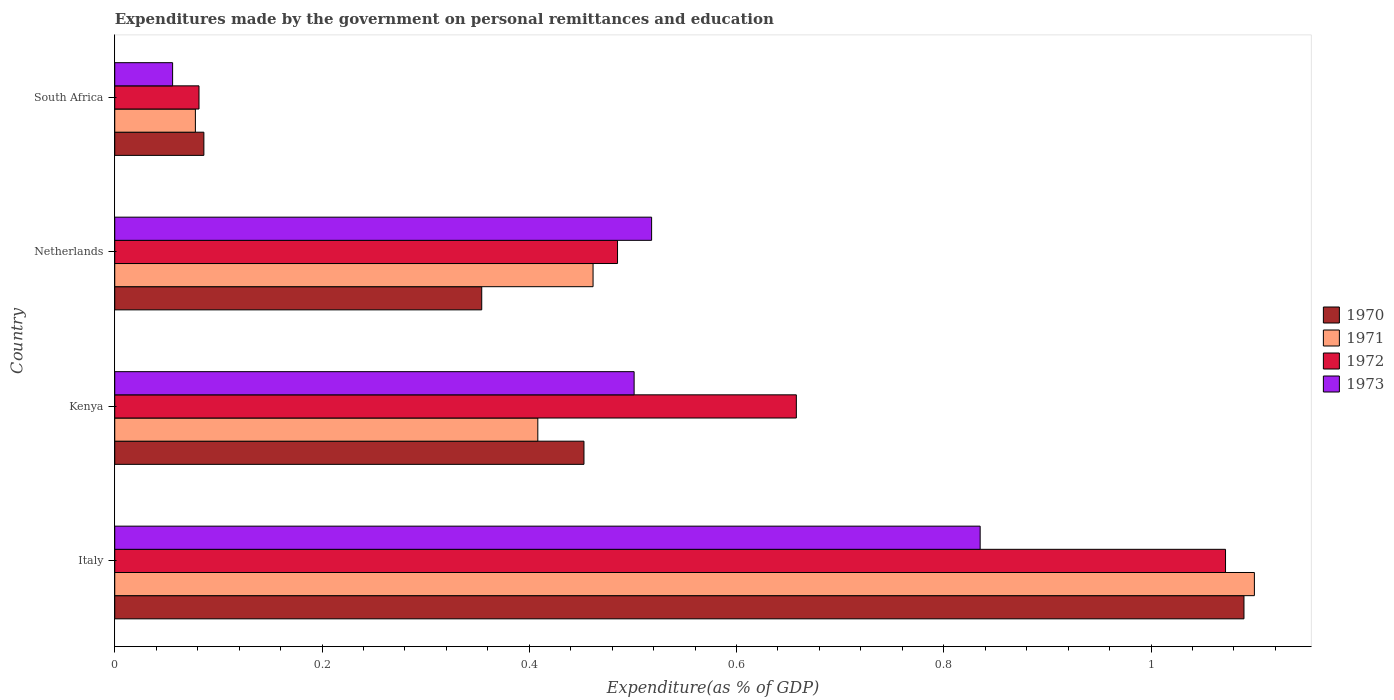How many groups of bars are there?
Your answer should be compact. 4. Are the number of bars per tick equal to the number of legend labels?
Your response must be concise. Yes. How many bars are there on the 3rd tick from the bottom?
Your response must be concise. 4. What is the label of the 4th group of bars from the top?
Your answer should be very brief. Italy. In how many cases, is the number of bars for a given country not equal to the number of legend labels?
Your answer should be very brief. 0. What is the expenditures made by the government on personal remittances and education in 1972 in South Africa?
Offer a terse response. 0.08. Across all countries, what is the maximum expenditures made by the government on personal remittances and education in 1973?
Your response must be concise. 0.84. Across all countries, what is the minimum expenditures made by the government on personal remittances and education in 1971?
Your answer should be very brief. 0.08. In which country was the expenditures made by the government on personal remittances and education in 1973 maximum?
Give a very brief answer. Italy. In which country was the expenditures made by the government on personal remittances and education in 1972 minimum?
Give a very brief answer. South Africa. What is the total expenditures made by the government on personal remittances and education in 1973 in the graph?
Give a very brief answer. 1.91. What is the difference between the expenditures made by the government on personal remittances and education in 1970 in Italy and that in South Africa?
Give a very brief answer. 1. What is the difference between the expenditures made by the government on personal remittances and education in 1973 in Italy and the expenditures made by the government on personal remittances and education in 1971 in Kenya?
Your answer should be compact. 0.43. What is the average expenditures made by the government on personal remittances and education in 1970 per country?
Your answer should be very brief. 0.5. What is the difference between the expenditures made by the government on personal remittances and education in 1972 and expenditures made by the government on personal remittances and education in 1970 in Kenya?
Give a very brief answer. 0.2. What is the ratio of the expenditures made by the government on personal remittances and education in 1971 in Italy to that in Kenya?
Provide a short and direct response. 2.69. Is the expenditures made by the government on personal remittances and education in 1970 in Kenya less than that in Netherlands?
Offer a very short reply. No. What is the difference between the highest and the second highest expenditures made by the government on personal remittances and education in 1971?
Offer a very short reply. 0.64. What is the difference between the highest and the lowest expenditures made by the government on personal remittances and education in 1971?
Give a very brief answer. 1.02. Is it the case that in every country, the sum of the expenditures made by the government on personal remittances and education in 1973 and expenditures made by the government on personal remittances and education in 1970 is greater than the sum of expenditures made by the government on personal remittances and education in 1971 and expenditures made by the government on personal remittances and education in 1972?
Your answer should be very brief. No. What does the 2nd bar from the bottom in Kenya represents?
Your response must be concise. 1971. Is it the case that in every country, the sum of the expenditures made by the government on personal remittances and education in 1973 and expenditures made by the government on personal remittances and education in 1970 is greater than the expenditures made by the government on personal remittances and education in 1972?
Give a very brief answer. Yes. Are all the bars in the graph horizontal?
Your response must be concise. Yes. What is the difference between two consecutive major ticks on the X-axis?
Your answer should be very brief. 0.2. Are the values on the major ticks of X-axis written in scientific E-notation?
Make the answer very short. No. Does the graph contain any zero values?
Offer a terse response. No. How many legend labels are there?
Ensure brevity in your answer.  4. What is the title of the graph?
Offer a terse response. Expenditures made by the government on personal remittances and education. Does "1993" appear as one of the legend labels in the graph?
Your answer should be very brief. No. What is the label or title of the X-axis?
Give a very brief answer. Expenditure(as % of GDP). What is the Expenditure(as % of GDP) in 1970 in Italy?
Your answer should be compact. 1.09. What is the Expenditure(as % of GDP) of 1971 in Italy?
Offer a very short reply. 1.1. What is the Expenditure(as % of GDP) of 1972 in Italy?
Your answer should be very brief. 1.07. What is the Expenditure(as % of GDP) of 1973 in Italy?
Keep it short and to the point. 0.84. What is the Expenditure(as % of GDP) in 1970 in Kenya?
Your answer should be very brief. 0.45. What is the Expenditure(as % of GDP) in 1971 in Kenya?
Provide a succinct answer. 0.41. What is the Expenditure(as % of GDP) of 1972 in Kenya?
Provide a succinct answer. 0.66. What is the Expenditure(as % of GDP) of 1973 in Kenya?
Your answer should be compact. 0.5. What is the Expenditure(as % of GDP) of 1970 in Netherlands?
Your answer should be very brief. 0.35. What is the Expenditure(as % of GDP) in 1971 in Netherlands?
Offer a terse response. 0.46. What is the Expenditure(as % of GDP) in 1972 in Netherlands?
Provide a short and direct response. 0.49. What is the Expenditure(as % of GDP) in 1973 in Netherlands?
Offer a terse response. 0.52. What is the Expenditure(as % of GDP) in 1970 in South Africa?
Provide a short and direct response. 0.09. What is the Expenditure(as % of GDP) of 1971 in South Africa?
Offer a very short reply. 0.08. What is the Expenditure(as % of GDP) in 1972 in South Africa?
Ensure brevity in your answer.  0.08. What is the Expenditure(as % of GDP) in 1973 in South Africa?
Offer a very short reply. 0.06. Across all countries, what is the maximum Expenditure(as % of GDP) in 1970?
Give a very brief answer. 1.09. Across all countries, what is the maximum Expenditure(as % of GDP) in 1971?
Ensure brevity in your answer.  1.1. Across all countries, what is the maximum Expenditure(as % of GDP) of 1972?
Provide a short and direct response. 1.07. Across all countries, what is the maximum Expenditure(as % of GDP) of 1973?
Offer a terse response. 0.84. Across all countries, what is the minimum Expenditure(as % of GDP) in 1970?
Make the answer very short. 0.09. Across all countries, what is the minimum Expenditure(as % of GDP) in 1971?
Keep it short and to the point. 0.08. Across all countries, what is the minimum Expenditure(as % of GDP) in 1972?
Give a very brief answer. 0.08. Across all countries, what is the minimum Expenditure(as % of GDP) in 1973?
Offer a terse response. 0.06. What is the total Expenditure(as % of GDP) in 1970 in the graph?
Your answer should be very brief. 1.98. What is the total Expenditure(as % of GDP) in 1971 in the graph?
Your response must be concise. 2.05. What is the total Expenditure(as % of GDP) in 1972 in the graph?
Ensure brevity in your answer.  2.3. What is the total Expenditure(as % of GDP) in 1973 in the graph?
Offer a very short reply. 1.91. What is the difference between the Expenditure(as % of GDP) in 1970 in Italy and that in Kenya?
Your answer should be compact. 0.64. What is the difference between the Expenditure(as % of GDP) of 1971 in Italy and that in Kenya?
Your answer should be compact. 0.69. What is the difference between the Expenditure(as % of GDP) in 1972 in Italy and that in Kenya?
Offer a terse response. 0.41. What is the difference between the Expenditure(as % of GDP) in 1973 in Italy and that in Kenya?
Give a very brief answer. 0.33. What is the difference between the Expenditure(as % of GDP) of 1970 in Italy and that in Netherlands?
Ensure brevity in your answer.  0.74. What is the difference between the Expenditure(as % of GDP) of 1971 in Italy and that in Netherlands?
Ensure brevity in your answer.  0.64. What is the difference between the Expenditure(as % of GDP) of 1972 in Italy and that in Netherlands?
Give a very brief answer. 0.59. What is the difference between the Expenditure(as % of GDP) of 1973 in Italy and that in Netherlands?
Offer a terse response. 0.32. What is the difference between the Expenditure(as % of GDP) of 1971 in Italy and that in South Africa?
Keep it short and to the point. 1.02. What is the difference between the Expenditure(as % of GDP) of 1972 in Italy and that in South Africa?
Make the answer very short. 0.99. What is the difference between the Expenditure(as % of GDP) of 1973 in Italy and that in South Africa?
Offer a terse response. 0.78. What is the difference between the Expenditure(as % of GDP) in 1970 in Kenya and that in Netherlands?
Provide a succinct answer. 0.1. What is the difference between the Expenditure(as % of GDP) of 1971 in Kenya and that in Netherlands?
Your answer should be compact. -0.05. What is the difference between the Expenditure(as % of GDP) of 1972 in Kenya and that in Netherlands?
Your response must be concise. 0.17. What is the difference between the Expenditure(as % of GDP) of 1973 in Kenya and that in Netherlands?
Provide a succinct answer. -0.02. What is the difference between the Expenditure(as % of GDP) in 1970 in Kenya and that in South Africa?
Your answer should be very brief. 0.37. What is the difference between the Expenditure(as % of GDP) of 1971 in Kenya and that in South Africa?
Make the answer very short. 0.33. What is the difference between the Expenditure(as % of GDP) of 1972 in Kenya and that in South Africa?
Offer a very short reply. 0.58. What is the difference between the Expenditure(as % of GDP) in 1973 in Kenya and that in South Africa?
Make the answer very short. 0.45. What is the difference between the Expenditure(as % of GDP) in 1970 in Netherlands and that in South Africa?
Your answer should be very brief. 0.27. What is the difference between the Expenditure(as % of GDP) in 1971 in Netherlands and that in South Africa?
Ensure brevity in your answer.  0.38. What is the difference between the Expenditure(as % of GDP) in 1972 in Netherlands and that in South Africa?
Ensure brevity in your answer.  0.4. What is the difference between the Expenditure(as % of GDP) of 1973 in Netherlands and that in South Africa?
Make the answer very short. 0.46. What is the difference between the Expenditure(as % of GDP) of 1970 in Italy and the Expenditure(as % of GDP) of 1971 in Kenya?
Ensure brevity in your answer.  0.68. What is the difference between the Expenditure(as % of GDP) of 1970 in Italy and the Expenditure(as % of GDP) of 1972 in Kenya?
Provide a short and direct response. 0.43. What is the difference between the Expenditure(as % of GDP) of 1970 in Italy and the Expenditure(as % of GDP) of 1973 in Kenya?
Give a very brief answer. 0.59. What is the difference between the Expenditure(as % of GDP) in 1971 in Italy and the Expenditure(as % of GDP) in 1972 in Kenya?
Give a very brief answer. 0.44. What is the difference between the Expenditure(as % of GDP) of 1971 in Italy and the Expenditure(as % of GDP) of 1973 in Kenya?
Your answer should be very brief. 0.6. What is the difference between the Expenditure(as % of GDP) in 1972 in Italy and the Expenditure(as % of GDP) in 1973 in Kenya?
Provide a short and direct response. 0.57. What is the difference between the Expenditure(as % of GDP) in 1970 in Italy and the Expenditure(as % of GDP) in 1971 in Netherlands?
Offer a very short reply. 0.63. What is the difference between the Expenditure(as % of GDP) in 1970 in Italy and the Expenditure(as % of GDP) in 1972 in Netherlands?
Your answer should be very brief. 0.6. What is the difference between the Expenditure(as % of GDP) in 1970 in Italy and the Expenditure(as % of GDP) in 1973 in Netherlands?
Offer a very short reply. 0.57. What is the difference between the Expenditure(as % of GDP) of 1971 in Italy and the Expenditure(as % of GDP) of 1972 in Netherlands?
Give a very brief answer. 0.61. What is the difference between the Expenditure(as % of GDP) in 1971 in Italy and the Expenditure(as % of GDP) in 1973 in Netherlands?
Offer a terse response. 0.58. What is the difference between the Expenditure(as % of GDP) of 1972 in Italy and the Expenditure(as % of GDP) of 1973 in Netherlands?
Make the answer very short. 0.55. What is the difference between the Expenditure(as % of GDP) in 1970 in Italy and the Expenditure(as % of GDP) in 1971 in South Africa?
Offer a very short reply. 1.01. What is the difference between the Expenditure(as % of GDP) of 1970 in Italy and the Expenditure(as % of GDP) of 1972 in South Africa?
Make the answer very short. 1.01. What is the difference between the Expenditure(as % of GDP) in 1970 in Italy and the Expenditure(as % of GDP) in 1973 in South Africa?
Offer a terse response. 1.03. What is the difference between the Expenditure(as % of GDP) in 1971 in Italy and the Expenditure(as % of GDP) in 1972 in South Africa?
Offer a very short reply. 1.02. What is the difference between the Expenditure(as % of GDP) in 1971 in Italy and the Expenditure(as % of GDP) in 1973 in South Africa?
Your response must be concise. 1.04. What is the difference between the Expenditure(as % of GDP) in 1970 in Kenya and the Expenditure(as % of GDP) in 1971 in Netherlands?
Make the answer very short. -0.01. What is the difference between the Expenditure(as % of GDP) of 1970 in Kenya and the Expenditure(as % of GDP) of 1972 in Netherlands?
Your answer should be compact. -0.03. What is the difference between the Expenditure(as % of GDP) in 1970 in Kenya and the Expenditure(as % of GDP) in 1973 in Netherlands?
Make the answer very short. -0.07. What is the difference between the Expenditure(as % of GDP) of 1971 in Kenya and the Expenditure(as % of GDP) of 1972 in Netherlands?
Offer a very short reply. -0.08. What is the difference between the Expenditure(as % of GDP) of 1971 in Kenya and the Expenditure(as % of GDP) of 1973 in Netherlands?
Provide a short and direct response. -0.11. What is the difference between the Expenditure(as % of GDP) in 1972 in Kenya and the Expenditure(as % of GDP) in 1973 in Netherlands?
Provide a short and direct response. 0.14. What is the difference between the Expenditure(as % of GDP) of 1970 in Kenya and the Expenditure(as % of GDP) of 1971 in South Africa?
Provide a short and direct response. 0.38. What is the difference between the Expenditure(as % of GDP) of 1970 in Kenya and the Expenditure(as % of GDP) of 1972 in South Africa?
Your answer should be compact. 0.37. What is the difference between the Expenditure(as % of GDP) in 1970 in Kenya and the Expenditure(as % of GDP) in 1973 in South Africa?
Offer a very short reply. 0.4. What is the difference between the Expenditure(as % of GDP) of 1971 in Kenya and the Expenditure(as % of GDP) of 1972 in South Africa?
Provide a succinct answer. 0.33. What is the difference between the Expenditure(as % of GDP) in 1971 in Kenya and the Expenditure(as % of GDP) in 1973 in South Africa?
Keep it short and to the point. 0.35. What is the difference between the Expenditure(as % of GDP) in 1972 in Kenya and the Expenditure(as % of GDP) in 1973 in South Africa?
Your response must be concise. 0.6. What is the difference between the Expenditure(as % of GDP) of 1970 in Netherlands and the Expenditure(as % of GDP) of 1971 in South Africa?
Provide a short and direct response. 0.28. What is the difference between the Expenditure(as % of GDP) of 1970 in Netherlands and the Expenditure(as % of GDP) of 1972 in South Africa?
Provide a short and direct response. 0.27. What is the difference between the Expenditure(as % of GDP) in 1970 in Netherlands and the Expenditure(as % of GDP) in 1973 in South Africa?
Offer a terse response. 0.3. What is the difference between the Expenditure(as % of GDP) of 1971 in Netherlands and the Expenditure(as % of GDP) of 1972 in South Africa?
Offer a terse response. 0.38. What is the difference between the Expenditure(as % of GDP) of 1971 in Netherlands and the Expenditure(as % of GDP) of 1973 in South Africa?
Your answer should be compact. 0.41. What is the difference between the Expenditure(as % of GDP) of 1972 in Netherlands and the Expenditure(as % of GDP) of 1973 in South Africa?
Keep it short and to the point. 0.43. What is the average Expenditure(as % of GDP) in 1970 per country?
Provide a succinct answer. 0.5. What is the average Expenditure(as % of GDP) of 1971 per country?
Provide a short and direct response. 0.51. What is the average Expenditure(as % of GDP) in 1972 per country?
Offer a terse response. 0.57. What is the average Expenditure(as % of GDP) of 1973 per country?
Make the answer very short. 0.48. What is the difference between the Expenditure(as % of GDP) in 1970 and Expenditure(as % of GDP) in 1971 in Italy?
Your response must be concise. -0.01. What is the difference between the Expenditure(as % of GDP) in 1970 and Expenditure(as % of GDP) in 1972 in Italy?
Your answer should be very brief. 0.02. What is the difference between the Expenditure(as % of GDP) in 1970 and Expenditure(as % of GDP) in 1973 in Italy?
Offer a very short reply. 0.25. What is the difference between the Expenditure(as % of GDP) of 1971 and Expenditure(as % of GDP) of 1972 in Italy?
Your response must be concise. 0.03. What is the difference between the Expenditure(as % of GDP) in 1971 and Expenditure(as % of GDP) in 1973 in Italy?
Your answer should be very brief. 0.26. What is the difference between the Expenditure(as % of GDP) in 1972 and Expenditure(as % of GDP) in 1973 in Italy?
Offer a very short reply. 0.24. What is the difference between the Expenditure(as % of GDP) of 1970 and Expenditure(as % of GDP) of 1971 in Kenya?
Keep it short and to the point. 0.04. What is the difference between the Expenditure(as % of GDP) in 1970 and Expenditure(as % of GDP) in 1972 in Kenya?
Keep it short and to the point. -0.2. What is the difference between the Expenditure(as % of GDP) in 1970 and Expenditure(as % of GDP) in 1973 in Kenya?
Provide a succinct answer. -0.05. What is the difference between the Expenditure(as % of GDP) of 1971 and Expenditure(as % of GDP) of 1972 in Kenya?
Your answer should be compact. -0.25. What is the difference between the Expenditure(as % of GDP) in 1971 and Expenditure(as % of GDP) in 1973 in Kenya?
Make the answer very short. -0.09. What is the difference between the Expenditure(as % of GDP) in 1972 and Expenditure(as % of GDP) in 1973 in Kenya?
Give a very brief answer. 0.16. What is the difference between the Expenditure(as % of GDP) in 1970 and Expenditure(as % of GDP) in 1971 in Netherlands?
Your response must be concise. -0.11. What is the difference between the Expenditure(as % of GDP) of 1970 and Expenditure(as % of GDP) of 1972 in Netherlands?
Make the answer very short. -0.13. What is the difference between the Expenditure(as % of GDP) in 1970 and Expenditure(as % of GDP) in 1973 in Netherlands?
Your response must be concise. -0.16. What is the difference between the Expenditure(as % of GDP) of 1971 and Expenditure(as % of GDP) of 1972 in Netherlands?
Offer a very short reply. -0.02. What is the difference between the Expenditure(as % of GDP) of 1971 and Expenditure(as % of GDP) of 1973 in Netherlands?
Your answer should be compact. -0.06. What is the difference between the Expenditure(as % of GDP) of 1972 and Expenditure(as % of GDP) of 1973 in Netherlands?
Provide a succinct answer. -0.03. What is the difference between the Expenditure(as % of GDP) in 1970 and Expenditure(as % of GDP) in 1971 in South Africa?
Your answer should be compact. 0.01. What is the difference between the Expenditure(as % of GDP) of 1970 and Expenditure(as % of GDP) of 1972 in South Africa?
Give a very brief answer. 0. What is the difference between the Expenditure(as % of GDP) of 1970 and Expenditure(as % of GDP) of 1973 in South Africa?
Ensure brevity in your answer.  0.03. What is the difference between the Expenditure(as % of GDP) in 1971 and Expenditure(as % of GDP) in 1972 in South Africa?
Give a very brief answer. -0. What is the difference between the Expenditure(as % of GDP) of 1971 and Expenditure(as % of GDP) of 1973 in South Africa?
Provide a succinct answer. 0.02. What is the difference between the Expenditure(as % of GDP) in 1972 and Expenditure(as % of GDP) in 1973 in South Africa?
Provide a succinct answer. 0.03. What is the ratio of the Expenditure(as % of GDP) in 1970 in Italy to that in Kenya?
Ensure brevity in your answer.  2.41. What is the ratio of the Expenditure(as % of GDP) of 1971 in Italy to that in Kenya?
Give a very brief answer. 2.69. What is the ratio of the Expenditure(as % of GDP) in 1972 in Italy to that in Kenya?
Your answer should be very brief. 1.63. What is the ratio of the Expenditure(as % of GDP) in 1973 in Italy to that in Kenya?
Ensure brevity in your answer.  1.67. What is the ratio of the Expenditure(as % of GDP) of 1970 in Italy to that in Netherlands?
Your answer should be very brief. 3.08. What is the ratio of the Expenditure(as % of GDP) in 1971 in Italy to that in Netherlands?
Provide a succinct answer. 2.38. What is the ratio of the Expenditure(as % of GDP) in 1972 in Italy to that in Netherlands?
Offer a terse response. 2.21. What is the ratio of the Expenditure(as % of GDP) in 1973 in Italy to that in Netherlands?
Provide a short and direct response. 1.61. What is the ratio of the Expenditure(as % of GDP) of 1970 in Italy to that in South Africa?
Provide a short and direct response. 12.67. What is the ratio of the Expenditure(as % of GDP) of 1971 in Italy to that in South Africa?
Keep it short and to the point. 14.13. What is the ratio of the Expenditure(as % of GDP) in 1972 in Italy to that in South Africa?
Provide a succinct answer. 13.18. What is the ratio of the Expenditure(as % of GDP) in 1973 in Italy to that in South Africa?
Make the answer very short. 14.96. What is the ratio of the Expenditure(as % of GDP) of 1970 in Kenya to that in Netherlands?
Provide a short and direct response. 1.28. What is the ratio of the Expenditure(as % of GDP) in 1971 in Kenya to that in Netherlands?
Provide a succinct answer. 0.88. What is the ratio of the Expenditure(as % of GDP) in 1972 in Kenya to that in Netherlands?
Give a very brief answer. 1.36. What is the ratio of the Expenditure(as % of GDP) in 1973 in Kenya to that in Netherlands?
Ensure brevity in your answer.  0.97. What is the ratio of the Expenditure(as % of GDP) of 1970 in Kenya to that in South Africa?
Offer a very short reply. 5.26. What is the ratio of the Expenditure(as % of GDP) in 1971 in Kenya to that in South Africa?
Give a very brief answer. 5.25. What is the ratio of the Expenditure(as % of GDP) of 1972 in Kenya to that in South Africa?
Give a very brief answer. 8.09. What is the ratio of the Expenditure(as % of GDP) in 1973 in Kenya to that in South Africa?
Give a very brief answer. 8.98. What is the ratio of the Expenditure(as % of GDP) in 1970 in Netherlands to that in South Africa?
Your answer should be very brief. 4.12. What is the ratio of the Expenditure(as % of GDP) of 1971 in Netherlands to that in South Africa?
Your response must be concise. 5.93. What is the ratio of the Expenditure(as % of GDP) in 1972 in Netherlands to that in South Africa?
Provide a short and direct response. 5.97. What is the ratio of the Expenditure(as % of GDP) in 1973 in Netherlands to that in South Africa?
Provide a succinct answer. 9.28. What is the difference between the highest and the second highest Expenditure(as % of GDP) of 1970?
Offer a very short reply. 0.64. What is the difference between the highest and the second highest Expenditure(as % of GDP) in 1971?
Make the answer very short. 0.64. What is the difference between the highest and the second highest Expenditure(as % of GDP) of 1972?
Ensure brevity in your answer.  0.41. What is the difference between the highest and the second highest Expenditure(as % of GDP) in 1973?
Offer a very short reply. 0.32. What is the difference between the highest and the lowest Expenditure(as % of GDP) in 1970?
Offer a very short reply. 1. What is the difference between the highest and the lowest Expenditure(as % of GDP) in 1971?
Offer a terse response. 1.02. What is the difference between the highest and the lowest Expenditure(as % of GDP) in 1972?
Provide a short and direct response. 0.99. What is the difference between the highest and the lowest Expenditure(as % of GDP) in 1973?
Your answer should be very brief. 0.78. 